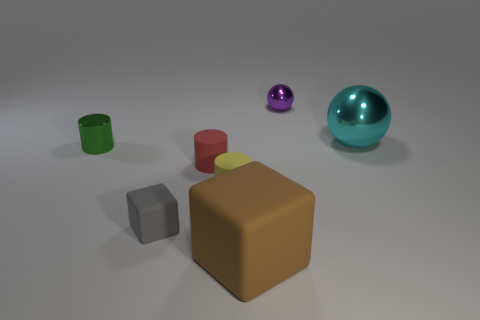Add 3 tiny red matte cylinders. How many objects exist? 10 Subtract all cylinders. How many objects are left? 4 Add 7 cyan things. How many cyan things are left? 8 Add 4 tiny yellow rubber cylinders. How many tiny yellow rubber cylinders exist? 5 Subtract 1 gray cubes. How many objects are left? 6 Subtract all big blue balls. Subtract all tiny red rubber cylinders. How many objects are left? 6 